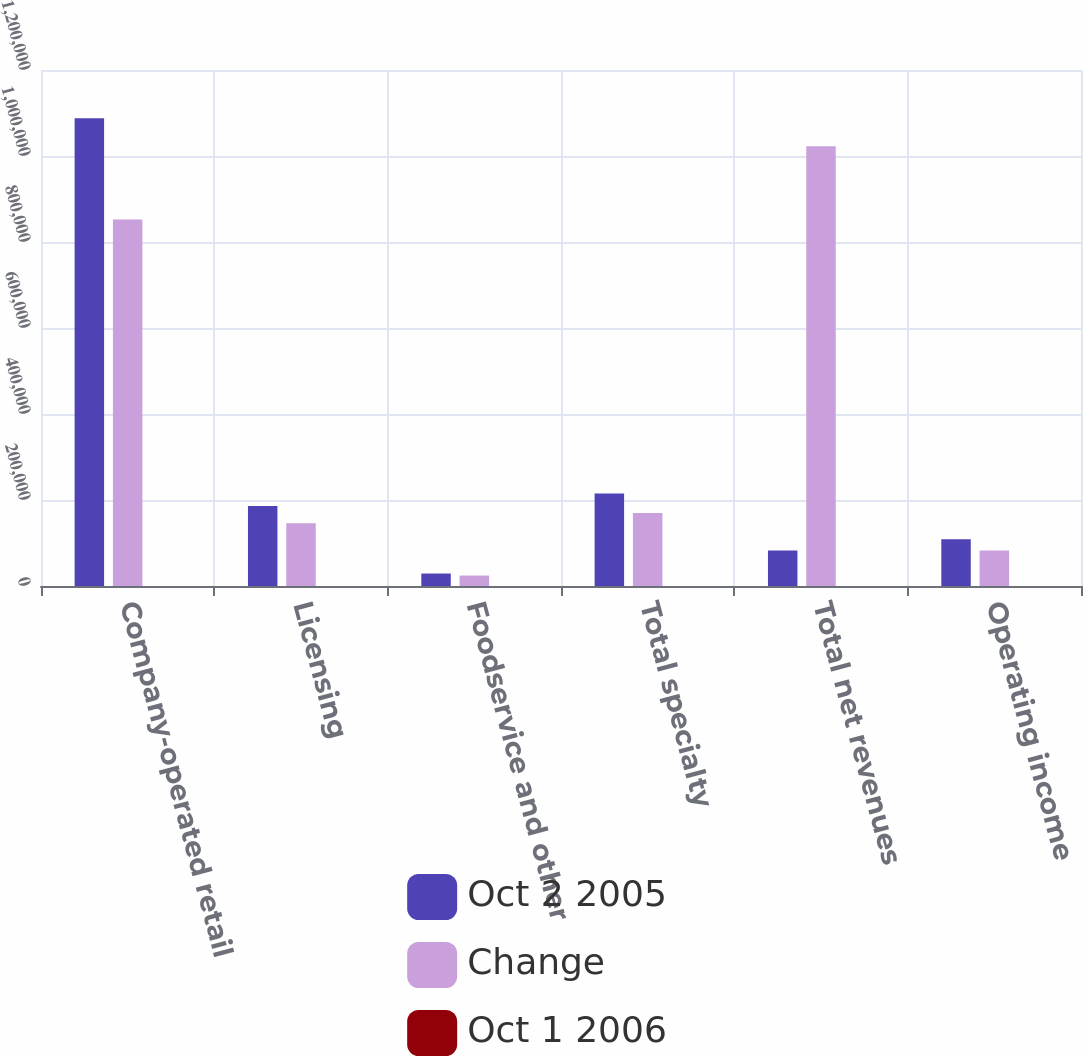<chart> <loc_0><loc_0><loc_500><loc_500><stacked_bar_chart><ecel><fcel>Company-operated retail<fcel>Licensing<fcel>Foodservice and other<fcel>Total specialty<fcel>Total net revenues<fcel>Operating income<nl><fcel>Oct 2 2005<fcel>1.08786e+06<fcel>186050<fcel>29006<fcel>215056<fcel>82299<fcel>108468<nl><fcel>Change<fcel>852472<fcel>145736<fcel>24285<fcel>170021<fcel>1.02249e+06<fcel>82299<nl><fcel>Oct 1 2006<fcel>27.6<fcel>27.7<fcel>19.4<fcel>26.5<fcel>27.4<fcel>31.8<nl></chart> 